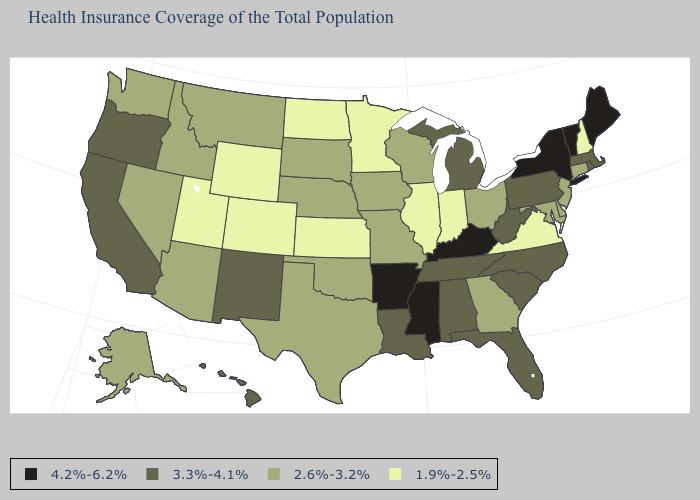What is the lowest value in states that border South Carolina?
Concise answer only. 2.6%-3.2%. Does the map have missing data?
Be succinct. No. What is the value of Maine?
Be succinct. 4.2%-6.2%. What is the value of Idaho?
Answer briefly. 2.6%-3.2%. Name the states that have a value in the range 4.2%-6.2%?
Short answer required. Arkansas, Kentucky, Maine, Mississippi, New York, Vermont. Which states have the lowest value in the South?
Quick response, please. Virginia. Does the first symbol in the legend represent the smallest category?
Keep it brief. No. What is the lowest value in the USA?
Short answer required. 1.9%-2.5%. What is the value of Kansas?
Quick response, please. 1.9%-2.5%. Does the first symbol in the legend represent the smallest category?
Be succinct. No. What is the highest value in the USA?
Concise answer only. 4.2%-6.2%. What is the value of Hawaii?
Be succinct. 3.3%-4.1%. Does Kansas have the same value as Colorado?
Short answer required. Yes. Does Maine have the highest value in the USA?
Short answer required. Yes. Name the states that have a value in the range 4.2%-6.2%?
Give a very brief answer. Arkansas, Kentucky, Maine, Mississippi, New York, Vermont. 